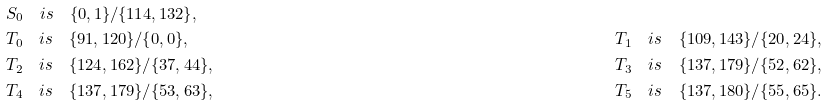<formula> <loc_0><loc_0><loc_500><loc_500>& S _ { 0 } \quad i s \quad \{ 0 , 1 \} / \{ 1 1 4 , 1 3 2 \} , & \\ & T _ { 0 } \quad i s \quad \{ 9 1 , 1 2 0 \} / \{ 0 , 0 \} , \quad & T _ { 1 } \quad i s \quad \{ 1 0 9 , 1 4 3 \} / \{ 2 0 , 2 4 \} , \\ & T _ { 2 } \quad i s \quad \{ 1 2 4 , 1 6 2 \} / \{ 3 7 , 4 4 \} , \quad & T _ { 3 } \quad i s \quad \{ 1 3 7 , 1 7 9 \} / \{ 5 2 , 6 2 \} , \\ & T _ { 4 } \quad i s \quad \{ 1 3 7 , 1 7 9 \} / \{ 5 3 , 6 3 \} , \quad & T _ { 5 } \quad i s \quad \{ 1 3 7 , 1 8 0 \} / \{ 5 5 , 6 5 \} .</formula> 